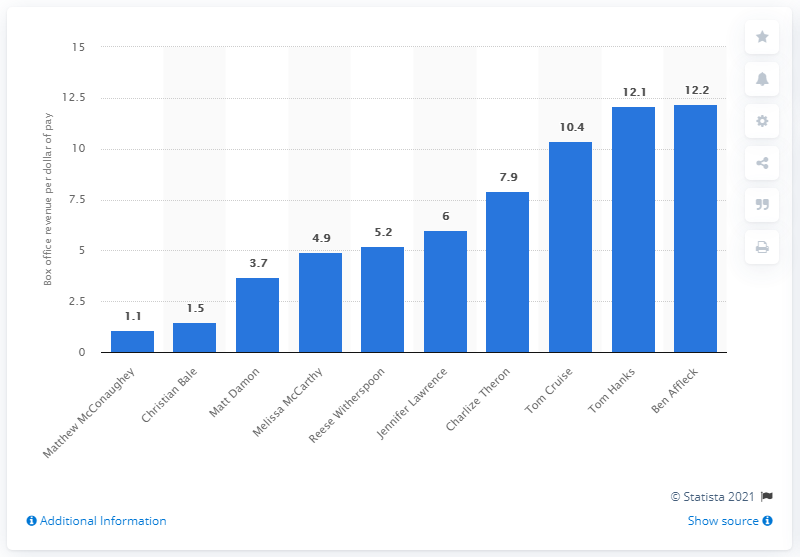Which actor ranked second on the list with 1.5 dollars per dollar of his pay?
 Christian Bale 